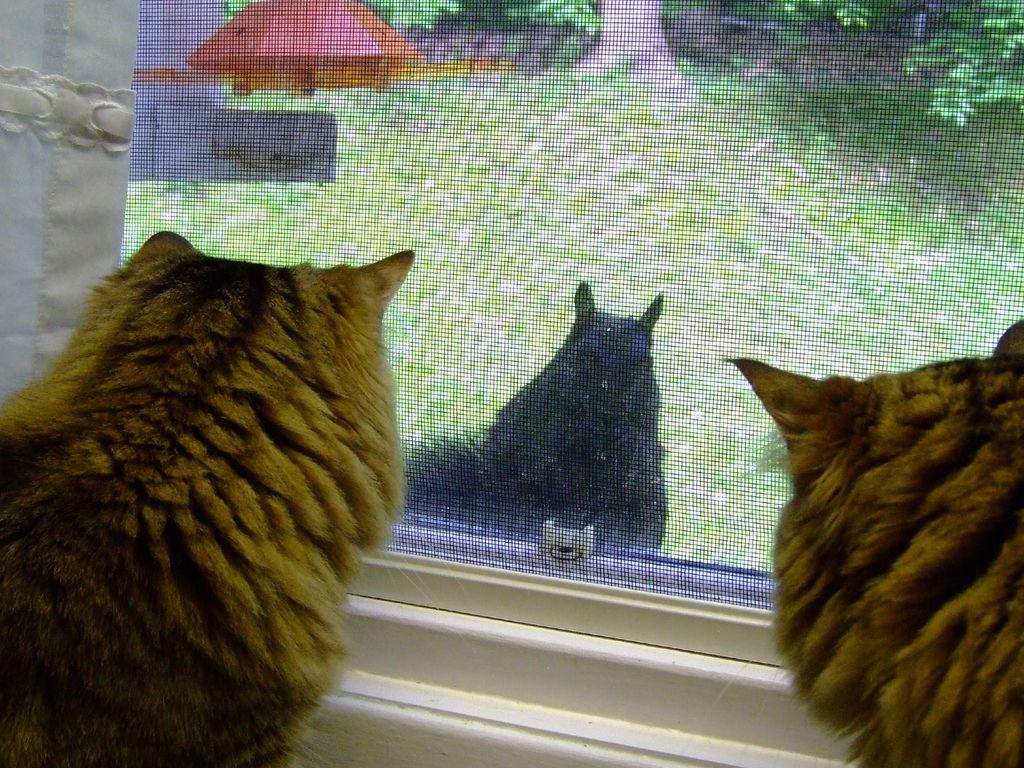How many animals can be seen in the image? There are two animals in the image. What is located in the background of the image? There is a screen and branches of trees in the background of the image. What can be seen on the screen? Another animal is visible on the screen. What type of cushion is being used by the animals in the image? There is no cushion present in the image; the animals are not using any cushions. 